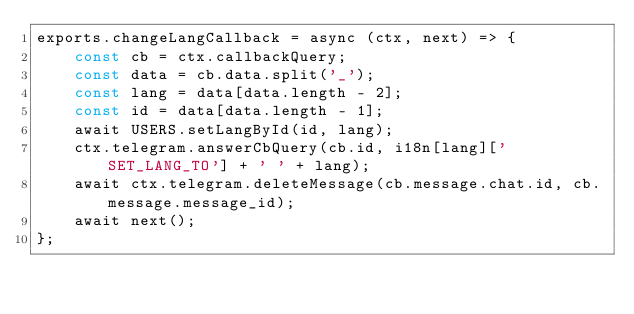<code> <loc_0><loc_0><loc_500><loc_500><_JavaScript_>exports.changeLangCallback = async (ctx, next) => {
    const cb = ctx.callbackQuery;
    const data = cb.data.split('_');
    const lang = data[data.length - 2];
    const id = data[data.length - 1];
    await USERS.setLangById(id, lang);
    ctx.telegram.answerCbQuery(cb.id, i18n[lang]['SET_LANG_TO'] + ' ' + lang);
    await ctx.telegram.deleteMessage(cb.message.chat.id, cb.message.message_id);
    await next();
};
</code> 